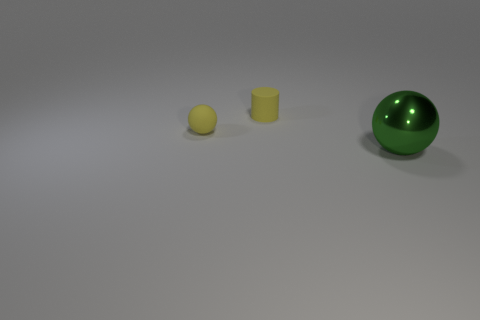Does the object that is in front of the small yellow ball have the same shape as the object that is left of the tiny matte cylinder?
Keep it short and to the point. Yes. Are there fewer yellow things that are on the right side of the yellow matte cylinder than yellow things behind the yellow rubber ball?
Ensure brevity in your answer.  Yes. There is a matte thing that is the same color as the cylinder; what is its shape?
Make the answer very short. Sphere. What number of rubber cylinders are the same size as the green metal thing?
Provide a short and direct response. 0. Does the green sphere that is in front of the yellow rubber cylinder have the same material as the cylinder?
Your response must be concise. No. Is there a small brown rubber cylinder?
Offer a terse response. No. Is there a matte object that has the same color as the small ball?
Your answer should be very brief. Yes. Do the thing that is left of the tiny yellow cylinder and the thing on the right side of the small rubber cylinder have the same color?
Make the answer very short. No. There is a cylinder that is the same color as the matte sphere; what size is it?
Your answer should be very brief. Small. Is there another sphere that has the same material as the tiny yellow sphere?
Make the answer very short. No. 